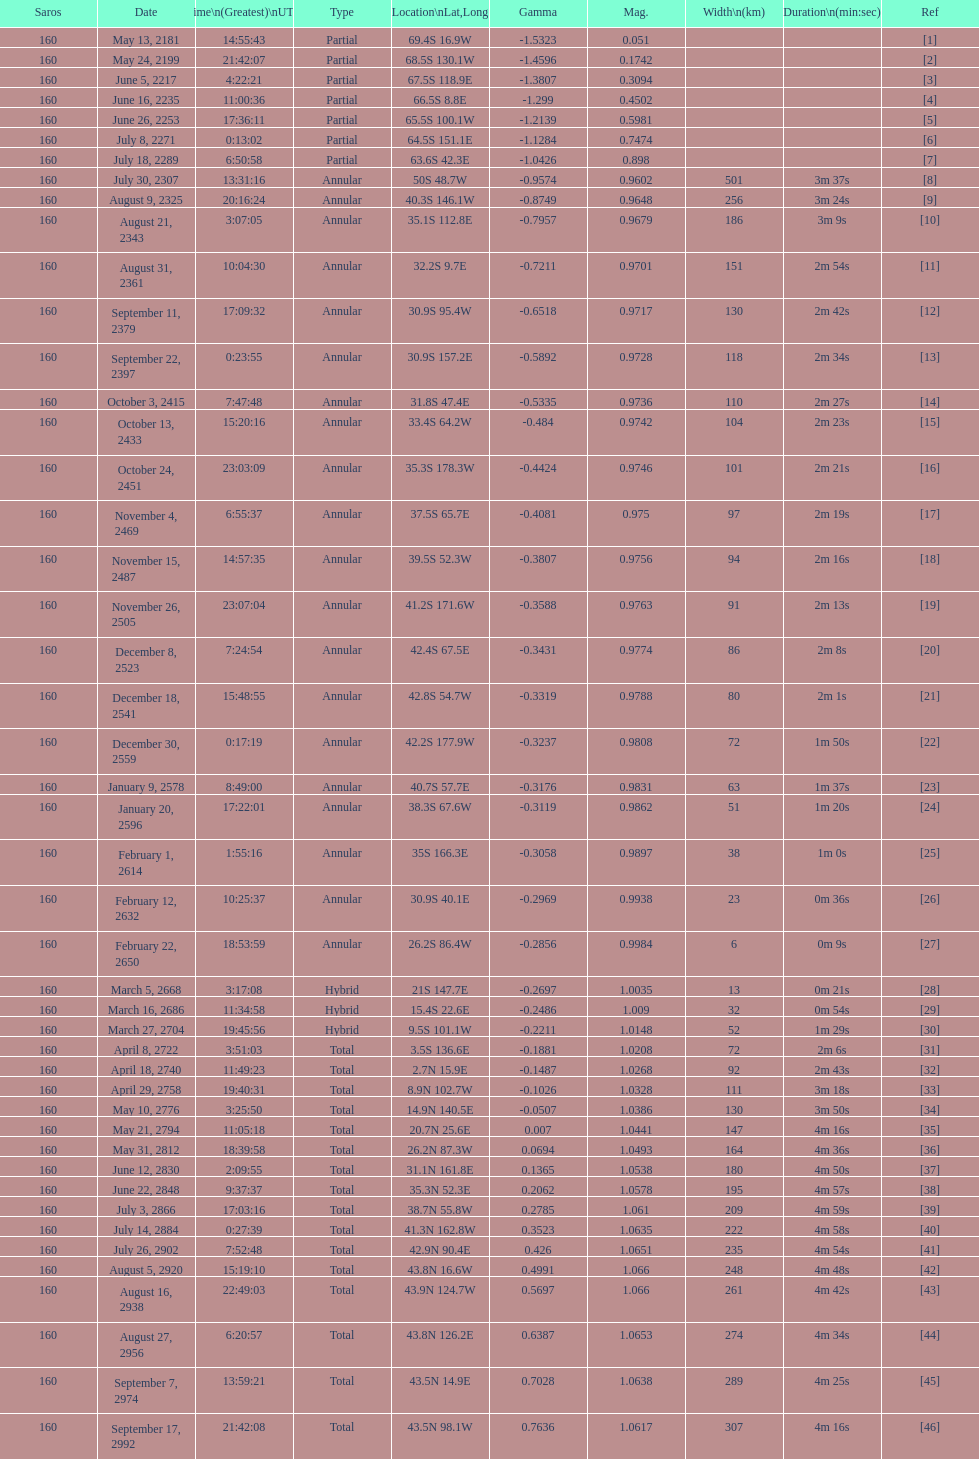Could you parse the entire table as a dict? {'header': ['Saros', 'Date', 'Time\\n(Greatest)\\nUTC', 'Type', 'Location\\nLat,Long', 'Gamma', 'Mag.', 'Width\\n(km)', 'Duration\\n(min:sec)', 'Ref'], 'rows': [['160', 'May 13, 2181', '14:55:43', 'Partial', '69.4S 16.9W', '-1.5323', '0.051', '', '', '[1]'], ['160', 'May 24, 2199', '21:42:07', 'Partial', '68.5S 130.1W', '-1.4596', '0.1742', '', '', '[2]'], ['160', 'June 5, 2217', '4:22:21', 'Partial', '67.5S 118.9E', '-1.3807', '0.3094', '', '', '[3]'], ['160', 'June 16, 2235', '11:00:36', 'Partial', '66.5S 8.8E', '-1.299', '0.4502', '', '', '[4]'], ['160', 'June 26, 2253', '17:36:11', 'Partial', '65.5S 100.1W', '-1.2139', '0.5981', '', '', '[5]'], ['160', 'July 8, 2271', '0:13:02', 'Partial', '64.5S 151.1E', '-1.1284', '0.7474', '', '', '[6]'], ['160', 'July 18, 2289', '6:50:58', 'Partial', '63.6S 42.3E', '-1.0426', '0.898', '', '', '[7]'], ['160', 'July 30, 2307', '13:31:16', 'Annular', '50S 48.7W', '-0.9574', '0.9602', '501', '3m 37s', '[8]'], ['160', 'August 9, 2325', '20:16:24', 'Annular', '40.3S 146.1W', '-0.8749', '0.9648', '256', '3m 24s', '[9]'], ['160', 'August 21, 2343', '3:07:05', 'Annular', '35.1S 112.8E', '-0.7957', '0.9679', '186', '3m 9s', '[10]'], ['160', 'August 31, 2361', '10:04:30', 'Annular', '32.2S 9.7E', '-0.7211', '0.9701', '151', '2m 54s', '[11]'], ['160', 'September 11, 2379', '17:09:32', 'Annular', '30.9S 95.4W', '-0.6518', '0.9717', '130', '2m 42s', '[12]'], ['160', 'September 22, 2397', '0:23:55', 'Annular', '30.9S 157.2E', '-0.5892', '0.9728', '118', '2m 34s', '[13]'], ['160', 'October 3, 2415', '7:47:48', 'Annular', '31.8S 47.4E', '-0.5335', '0.9736', '110', '2m 27s', '[14]'], ['160', 'October 13, 2433', '15:20:16', 'Annular', '33.4S 64.2W', '-0.484', '0.9742', '104', '2m 23s', '[15]'], ['160', 'October 24, 2451', '23:03:09', 'Annular', '35.3S 178.3W', '-0.4424', '0.9746', '101', '2m 21s', '[16]'], ['160', 'November 4, 2469', '6:55:37', 'Annular', '37.5S 65.7E', '-0.4081', '0.975', '97', '2m 19s', '[17]'], ['160', 'November 15, 2487', '14:57:35', 'Annular', '39.5S 52.3W', '-0.3807', '0.9756', '94', '2m 16s', '[18]'], ['160', 'November 26, 2505', '23:07:04', 'Annular', '41.2S 171.6W', '-0.3588', '0.9763', '91', '2m 13s', '[19]'], ['160', 'December 8, 2523', '7:24:54', 'Annular', '42.4S 67.5E', '-0.3431', '0.9774', '86', '2m 8s', '[20]'], ['160', 'December 18, 2541', '15:48:55', 'Annular', '42.8S 54.7W', '-0.3319', '0.9788', '80', '2m 1s', '[21]'], ['160', 'December 30, 2559', '0:17:19', 'Annular', '42.2S 177.9W', '-0.3237', '0.9808', '72', '1m 50s', '[22]'], ['160', 'January 9, 2578', '8:49:00', 'Annular', '40.7S 57.7E', '-0.3176', '0.9831', '63', '1m 37s', '[23]'], ['160', 'January 20, 2596', '17:22:01', 'Annular', '38.3S 67.6W', '-0.3119', '0.9862', '51', '1m 20s', '[24]'], ['160', 'February 1, 2614', '1:55:16', 'Annular', '35S 166.3E', '-0.3058', '0.9897', '38', '1m 0s', '[25]'], ['160', 'February 12, 2632', '10:25:37', 'Annular', '30.9S 40.1E', '-0.2969', '0.9938', '23', '0m 36s', '[26]'], ['160', 'February 22, 2650', '18:53:59', 'Annular', '26.2S 86.4W', '-0.2856', '0.9984', '6', '0m 9s', '[27]'], ['160', 'March 5, 2668', '3:17:08', 'Hybrid', '21S 147.7E', '-0.2697', '1.0035', '13', '0m 21s', '[28]'], ['160', 'March 16, 2686', '11:34:58', 'Hybrid', '15.4S 22.6E', '-0.2486', '1.009', '32', '0m 54s', '[29]'], ['160', 'March 27, 2704', '19:45:56', 'Hybrid', '9.5S 101.1W', '-0.2211', '1.0148', '52', '1m 29s', '[30]'], ['160', 'April 8, 2722', '3:51:03', 'Total', '3.5S 136.6E', '-0.1881', '1.0208', '72', '2m 6s', '[31]'], ['160', 'April 18, 2740', '11:49:23', 'Total', '2.7N 15.9E', '-0.1487', '1.0268', '92', '2m 43s', '[32]'], ['160', 'April 29, 2758', '19:40:31', 'Total', '8.9N 102.7W', '-0.1026', '1.0328', '111', '3m 18s', '[33]'], ['160', 'May 10, 2776', '3:25:50', 'Total', '14.9N 140.5E', '-0.0507', '1.0386', '130', '3m 50s', '[34]'], ['160', 'May 21, 2794', '11:05:18', 'Total', '20.7N 25.6E', '0.007', '1.0441', '147', '4m 16s', '[35]'], ['160', 'May 31, 2812', '18:39:58', 'Total', '26.2N 87.3W', '0.0694', '1.0493', '164', '4m 36s', '[36]'], ['160', 'June 12, 2830', '2:09:55', 'Total', '31.1N 161.8E', '0.1365', '1.0538', '180', '4m 50s', '[37]'], ['160', 'June 22, 2848', '9:37:37', 'Total', '35.3N 52.3E', '0.2062', '1.0578', '195', '4m 57s', '[38]'], ['160', 'July 3, 2866', '17:03:16', 'Total', '38.7N 55.8W', '0.2785', '1.061', '209', '4m 59s', '[39]'], ['160', 'July 14, 2884', '0:27:39', 'Total', '41.3N 162.8W', '0.3523', '1.0635', '222', '4m 58s', '[40]'], ['160', 'July 26, 2902', '7:52:48', 'Total', '42.9N 90.4E', '0.426', '1.0651', '235', '4m 54s', '[41]'], ['160', 'August 5, 2920', '15:19:10', 'Total', '43.8N 16.6W', '0.4991', '1.066', '248', '4m 48s', '[42]'], ['160', 'August 16, 2938', '22:49:03', 'Total', '43.9N 124.7W', '0.5697', '1.066', '261', '4m 42s', '[43]'], ['160', 'August 27, 2956', '6:20:57', 'Total', '43.8N 126.2E', '0.6387', '1.0653', '274', '4m 34s', '[44]'], ['160', 'September 7, 2974', '13:59:21', 'Total', '43.5N 14.9E', '0.7028', '1.0638', '289', '4m 25s', '[45]'], ['160', 'September 17, 2992', '21:42:08', 'Total', '43.5N 98.1W', '0.7636', '1.0617', '307', '4m 16s', '[46]']]} Name a member number with a latitude above 60 s. 1. 